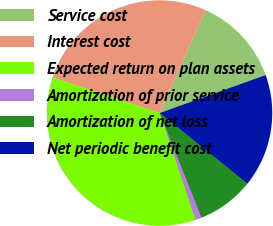Convert chart to OTSL. <chart><loc_0><loc_0><loc_500><loc_500><pie_chart><fcel>Service cost<fcel>Interest cost<fcel>Expected return on plan assets<fcel>Amortization of prior service<fcel>Amortization of net loss<fcel>Net periodic benefit cost<nl><fcel>12.84%<fcel>26.58%<fcel>35.24%<fcel>0.92%<fcel>8.15%<fcel>16.27%<nl></chart> 